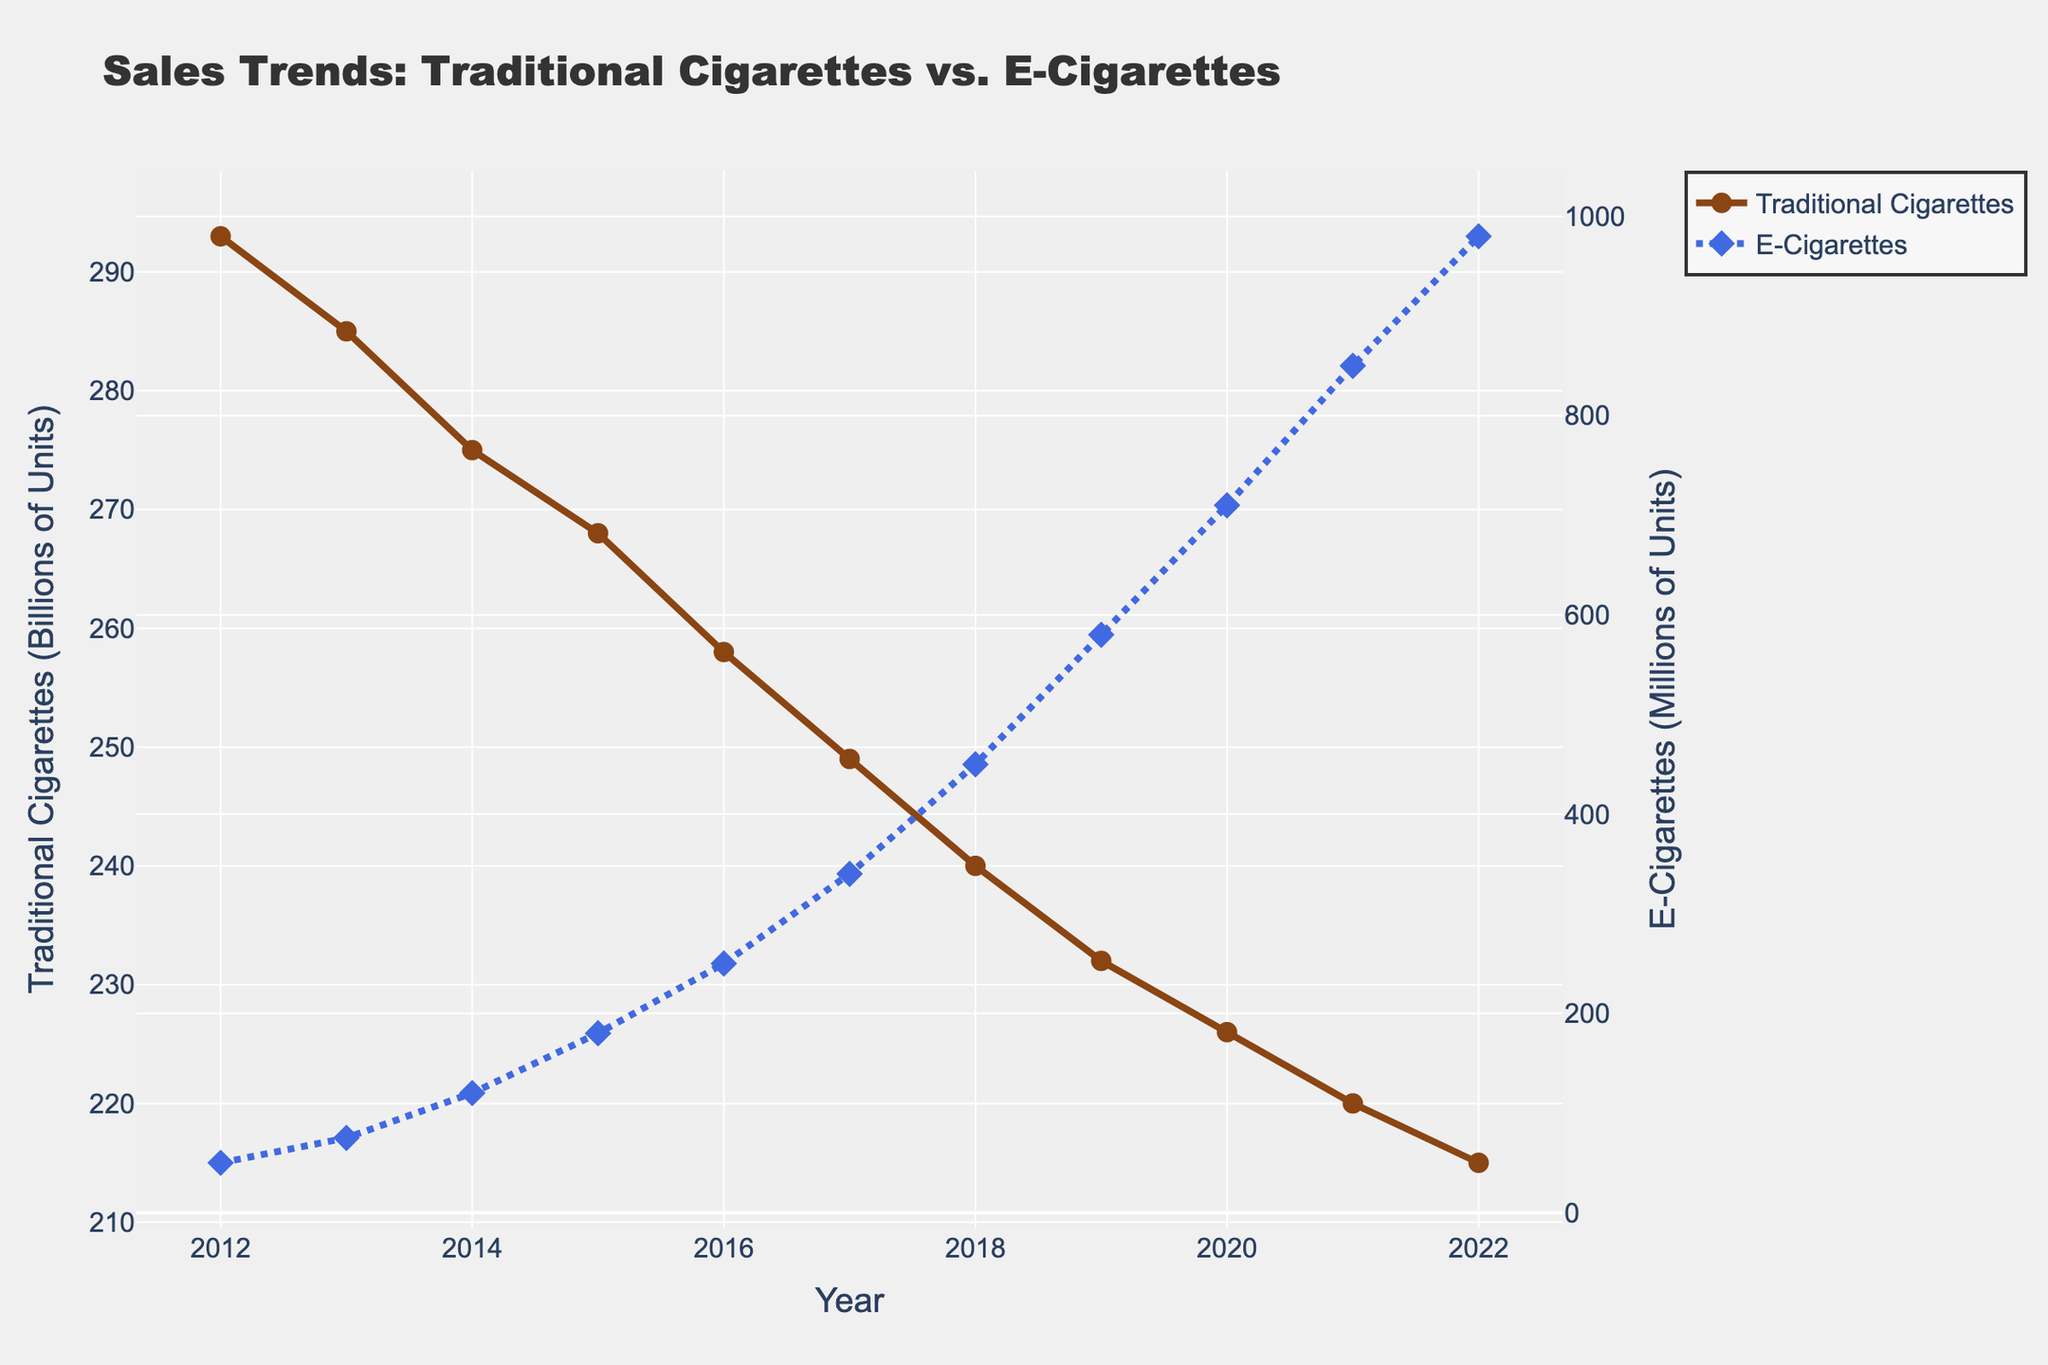what is the general trend for traditional cigarettes over the past decade? Over the past decade, the sales of traditional cigarettes show a downward trend. This can be observed by looking at the decreasing line representing traditional cigarettes on the graph, which starts at 293 billion units in 2012 and declines steadily to 215 billion units in 2022.
Answer: Downward trend How do the sales trends of traditional cigarettes and e-cigarettes compare from 2012 to 2022? The traditional cigarettes show a consistent decline over the years from 293 billion units in 2012 to 215 billion units in 2022. Conversely, e-cigarettes exhibit an increasing trend, starting from 50 million units in 2012 and rising significantly to 980 million units by 2022.
Answer: Traditional cigarettes decline, e-cigarettes increase What specific year did e-cigarette sales first surpass 500 million units? The e-cigarette sales first surpassed 500 million units in 2019, where the sales reached 580 million units. This can be seen from the data on the graph, with the line for e-cigarettes crossing the 500 million unit mark in 2019.
Answer: 2019 Which year saw the fastest increase in e-cigarette sales? Between 2018 and 2019, the e-cigarette sales increased from 450 million units to 580 million units. This increase of 130 million units in one year is the largest increment seen on the graph for e-cigarette sales.
Answer: 2018-2019 By how much did traditional cigarette sales decrease from 2012 to 2022? Traditional cigarette sales decreased from 293 billion units in 2012 to 215 billion units in 2022. The decrease can be calculated by subtracting 215 from 293, resulting in a decrease of 78 billion units.
Answer: 78 billion units In which year were traditional cigarette sales the closest to e-cigarette sales when both are considered in the same unit before converting? In 2012, traditional cigarette sales were 293 billion units and e-cigarette sales were 50 million units, making them the most distant. By 2022, traditional cigarette sales decreased to 215 billion units and e-cigarette sales increased to 980 million units (0.98 billion units). The gap is smallest as traditional cigarettes (215 billion) are closest to e-cigarettes (0.98 billion).
Answer: 2022 What is the average annual increase in e-cigarette sales from 2012 to 2022? The total increase in e-cigarette sales from 50 million units in 2012 to 980 million units in 2022 is 930 million units over 10 years. The average annual increase is calculated by dividing 930 by 10, resulting in an average annual increase of 93 million units.
Answer: 93 million units Considering both products, what is the combined sales in billion units for the year 2015? In 2015, traditional cigarette sales were 268 billion units. E-cigarette sales were 180 million units, or 0.18 billion units. The combined sales are 268 + 0.18, which equals 268.18 billion units.
Answer: 268.18 billion units 